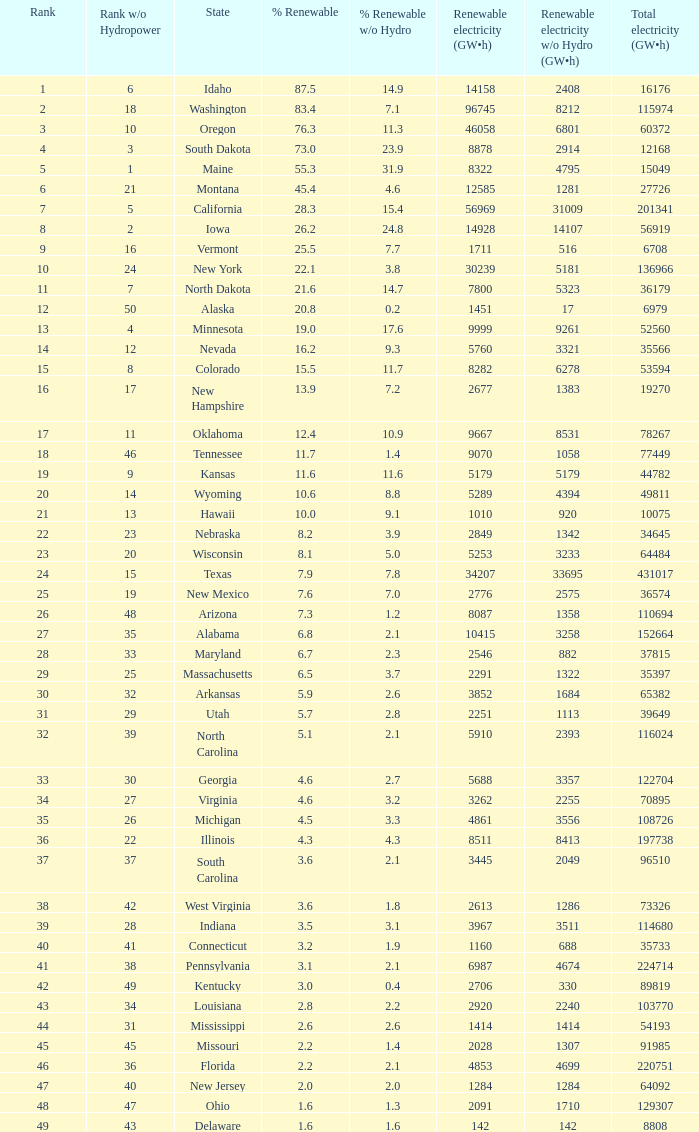What is the utmost renewable energy (gw×h) for the state of delaware? 142.0. 